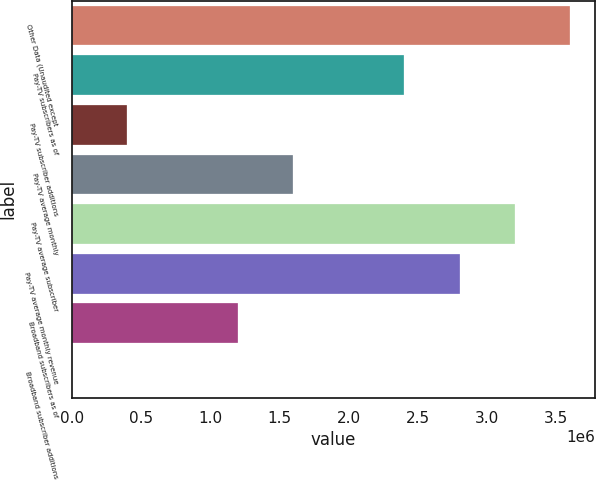Convert chart. <chart><loc_0><loc_0><loc_500><loc_500><bar_chart><fcel>Other Data (Unaudited except<fcel>Pay-TV subscribers as of<fcel>Pay-TV subscriber additions<fcel>Pay-TV average monthly<fcel>Pay-TV average subscriber<fcel>Pay-TV average monthly revenue<fcel>Broadband subscribers as of<fcel>Broadband subscriber additions<nl><fcel>3.60354e+06<fcel>2.40236e+06<fcel>400393<fcel>1.60157e+06<fcel>3.20315e+06<fcel>2.80275e+06<fcel>1.20118e+06<fcel>0.08<nl></chart> 